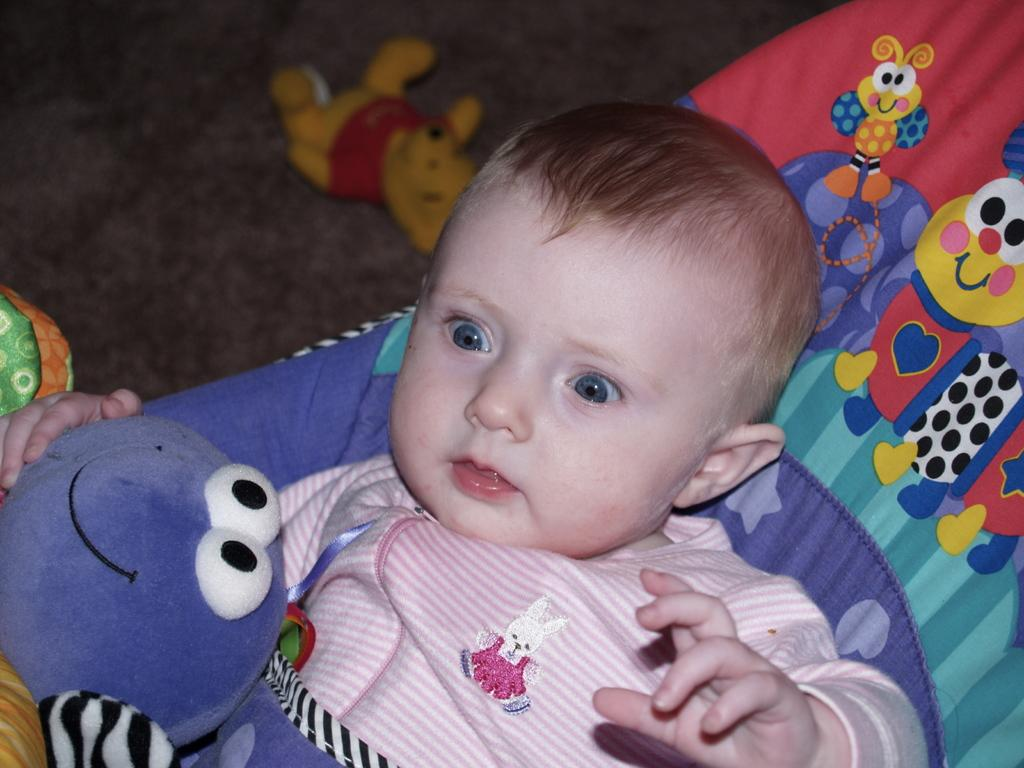What type of material is present in the image? There is cloth in the image. What else can be seen in the image besides the cloth? There are toys and a child in the image. Can you describe the child's clothing in the image? The child is wearing a pink dress. What type of potato is being sorted in the office in the image? There is no potato or office present in the image. What type of work might be done in the office in the image? There is no office present in the image, so it is not possible to determine what type of work might be done there. 